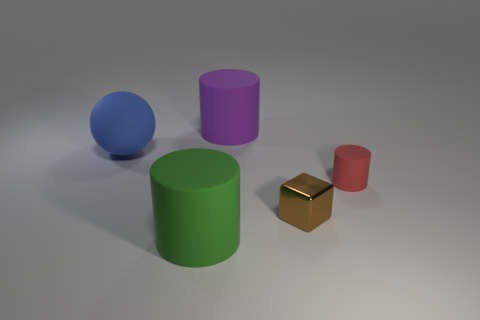Subtract all tiny cylinders. How many cylinders are left? 2 Subtract all green cylinders. How many cylinders are left? 2 Add 5 large spheres. How many objects exist? 10 Subtract all cylinders. How many objects are left? 2 Subtract 0 gray cubes. How many objects are left? 5 Subtract 1 balls. How many balls are left? 0 Subtract all green cylinders. Subtract all blue cubes. How many cylinders are left? 2 Subtract all red balls. How many red cylinders are left? 1 Subtract all green matte things. Subtract all big green cubes. How many objects are left? 4 Add 2 big purple things. How many big purple things are left? 3 